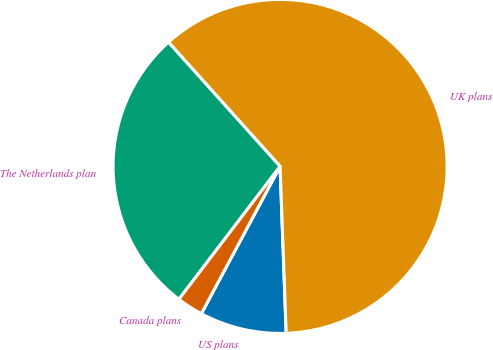Convert chart to OTSL. <chart><loc_0><loc_0><loc_500><loc_500><pie_chart><fcel>US plans<fcel>UK plans<fcel>The Netherlands plan<fcel>Canada plans<nl><fcel>8.4%<fcel>61.07%<fcel>27.99%<fcel>2.54%<nl></chart> 